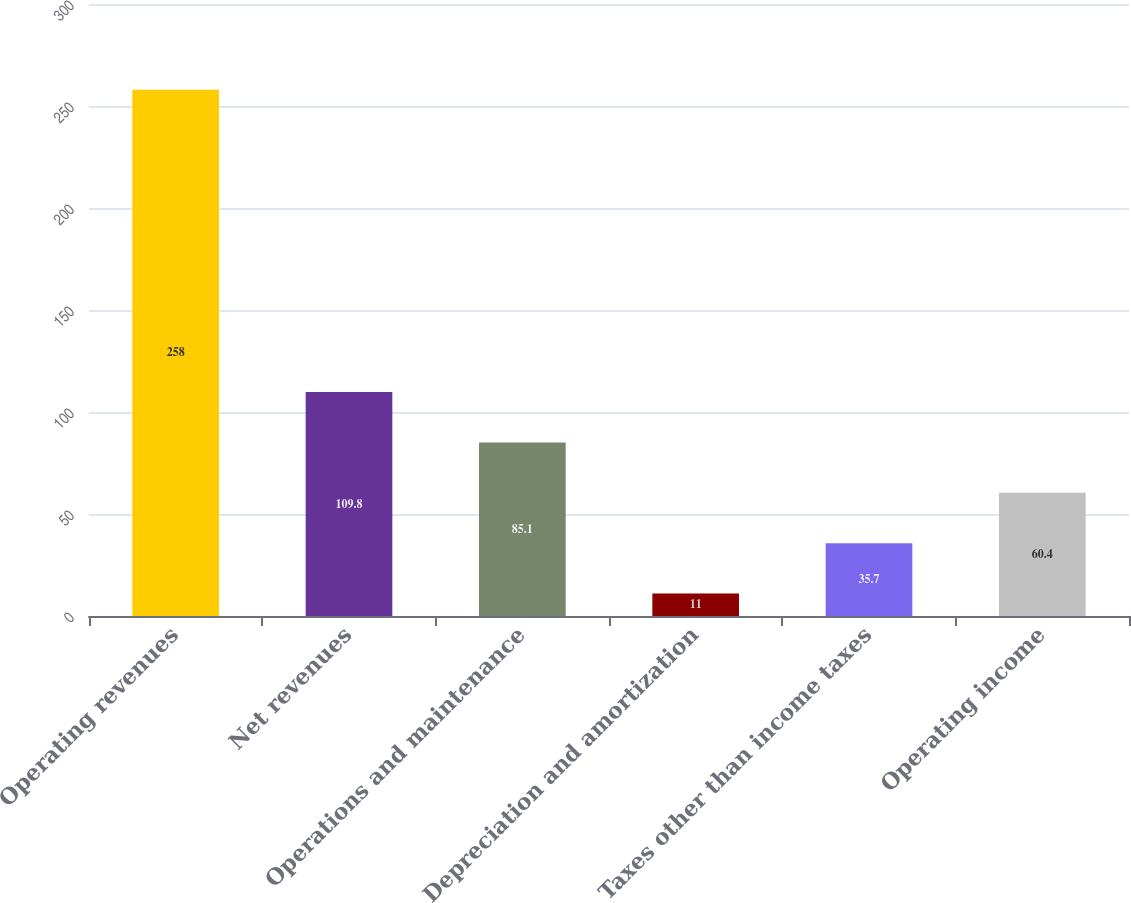Convert chart to OTSL. <chart><loc_0><loc_0><loc_500><loc_500><bar_chart><fcel>Operating revenues<fcel>Net revenues<fcel>Operations and maintenance<fcel>Depreciation and amortization<fcel>Taxes other than income taxes<fcel>Operating income<nl><fcel>258<fcel>109.8<fcel>85.1<fcel>11<fcel>35.7<fcel>60.4<nl></chart> 